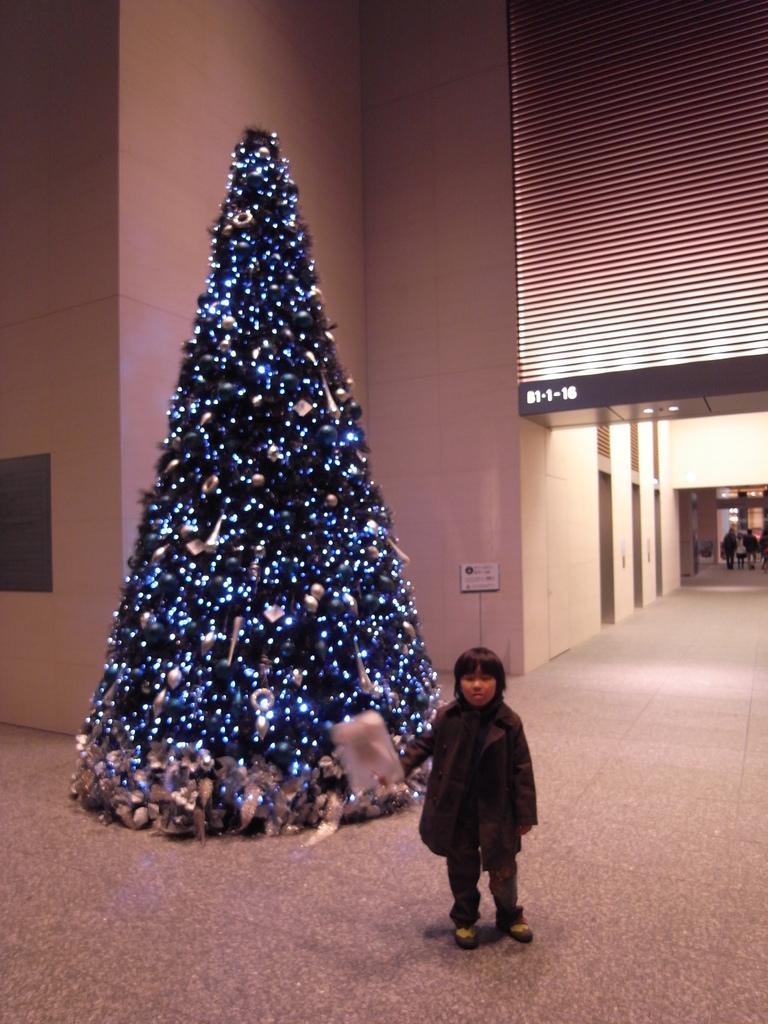Could you give a brief overview of what you see in this image? In the image in the center, we can see one kid standing and holding paper. In the background there is a wall, signboard, board, Christmas tree, few people are standing and few other objects. 